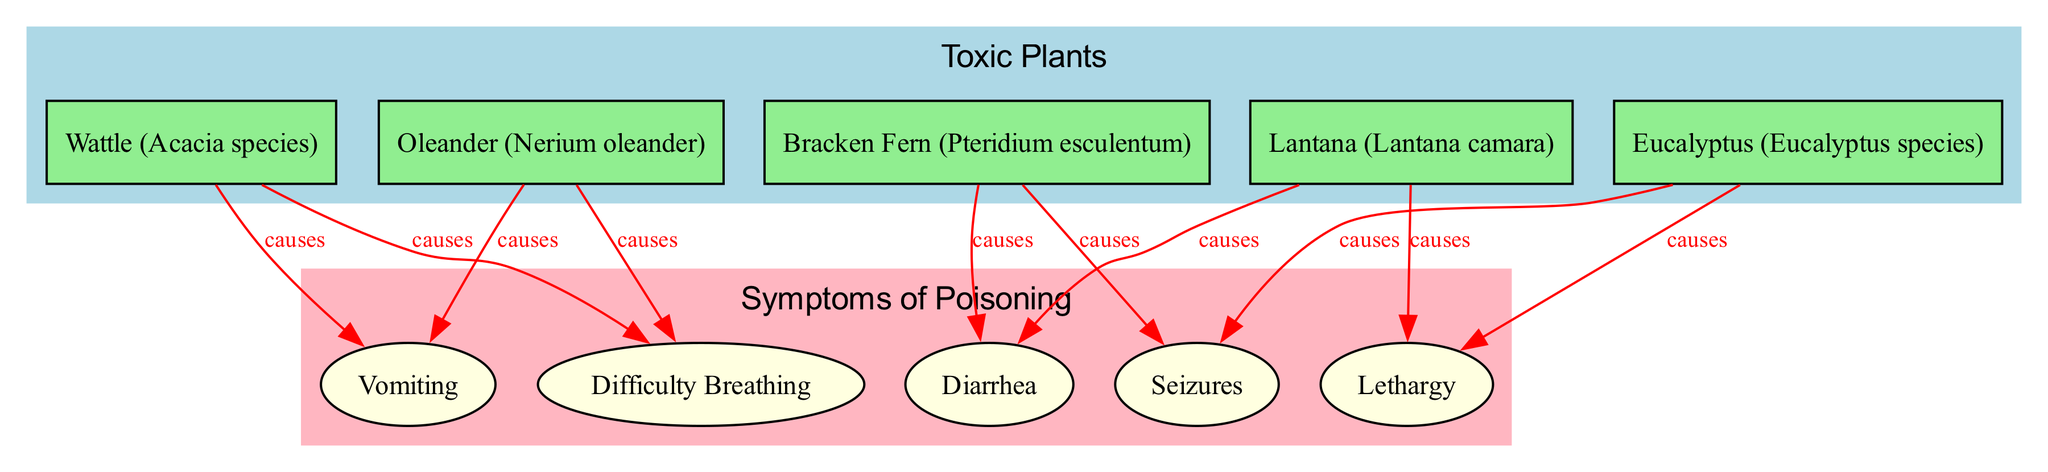What plants are included in the "Toxic Plants" category? The "Toxic Plants" category includes five nodes: Oleander, Bracken Fern, Lantana, Wattle, and Eucalyptus. These plants are directly connected to the "Toxic Plants" node with the label "includes."
Answer: Oleander, Bracken Fern, Lantana, Wattle, Eucalyptus How many symptoms of poisoning are listed in the diagram? The diagram lists five symptoms: Vomiting, Diarrhea, Lethargy, Difficulty Breathing, and Seizures. These symptoms are connected to the "Symptoms of Poisoning" node with the label "includes."
Answer: Five What symptom is caused by Oleander? Oleander causes Vomiting and Difficulty Breathing, as indicated by the edges connecting the Oleander node to these symptoms with the label "causes."
Answer: Vomiting, Difficulty Breathing Which toxic plant causes both Vomiting and Diarrhea? Lantana causes Diarrhea and Vomiting, as evidenced by the edges linking Lantana to these symptoms with the label "causes."
Answer: Lantana How many total edges are there in the diagram? The diagram has a total of ten edges. They include connections showing which plants are included under "Toxic Plants," symptoms included under "Symptoms of Poisoning," and the causal relationships from specific plants to their symptoms.
Answer: Ten 